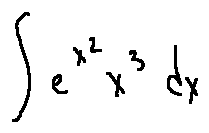<formula> <loc_0><loc_0><loc_500><loc_500>\int e ^ { x ^ { 2 } } x ^ { 3 } d x</formula> 